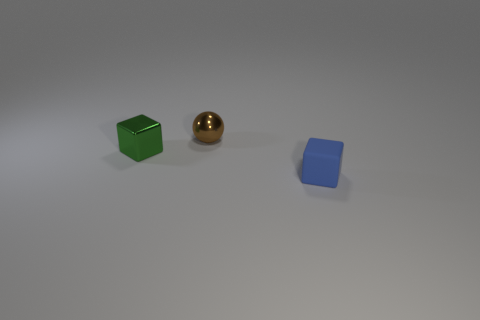Is the color of the object that is to the right of the metallic sphere the same as the tiny block left of the small blue matte block?
Offer a terse response. No. The block that is the same size as the blue object is what color?
Your response must be concise. Green. How many other things are there of the same shape as the blue thing?
Keep it short and to the point. 1. There is a block behind the tiny blue rubber thing; what is its size?
Make the answer very short. Small. There is a tiny cube that is on the left side of the brown shiny thing; what number of things are behind it?
Provide a succinct answer. 1. How many other objects are the same size as the brown sphere?
Give a very brief answer. 2. Do the small shiny sphere and the matte thing have the same color?
Your answer should be compact. No. There is a tiny metal object that is left of the shiny ball; is it the same shape as the small blue object?
Your response must be concise. Yes. How many tiny blocks are both on the right side of the shiny sphere and behind the matte cube?
Ensure brevity in your answer.  0. What is the small green cube made of?
Your response must be concise. Metal. 